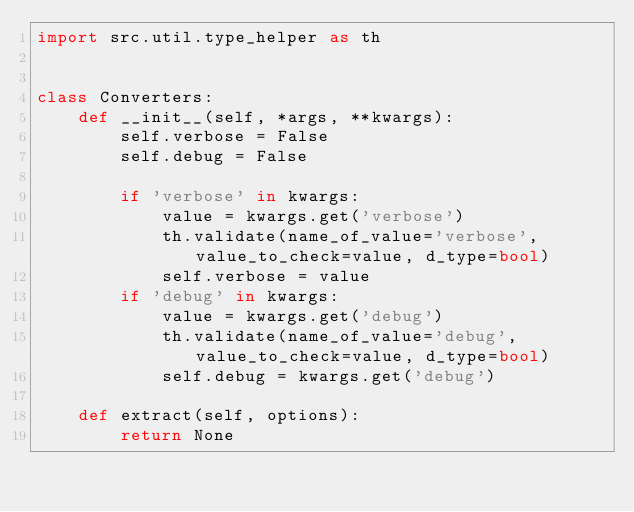Convert code to text. <code><loc_0><loc_0><loc_500><loc_500><_Python_>import src.util.type_helper as th


class Converters:
    def __init__(self, *args, **kwargs):
        self.verbose = False
        self.debug = False

        if 'verbose' in kwargs:
            value = kwargs.get('verbose')
            th.validate(name_of_value='verbose', value_to_check=value, d_type=bool)
            self.verbose = value
        if 'debug' in kwargs:
            value = kwargs.get('debug')
            th.validate(name_of_value='debug', value_to_check=value, d_type=bool)
            self.debug = kwargs.get('debug')

    def extract(self, options):
        return None
</code> 